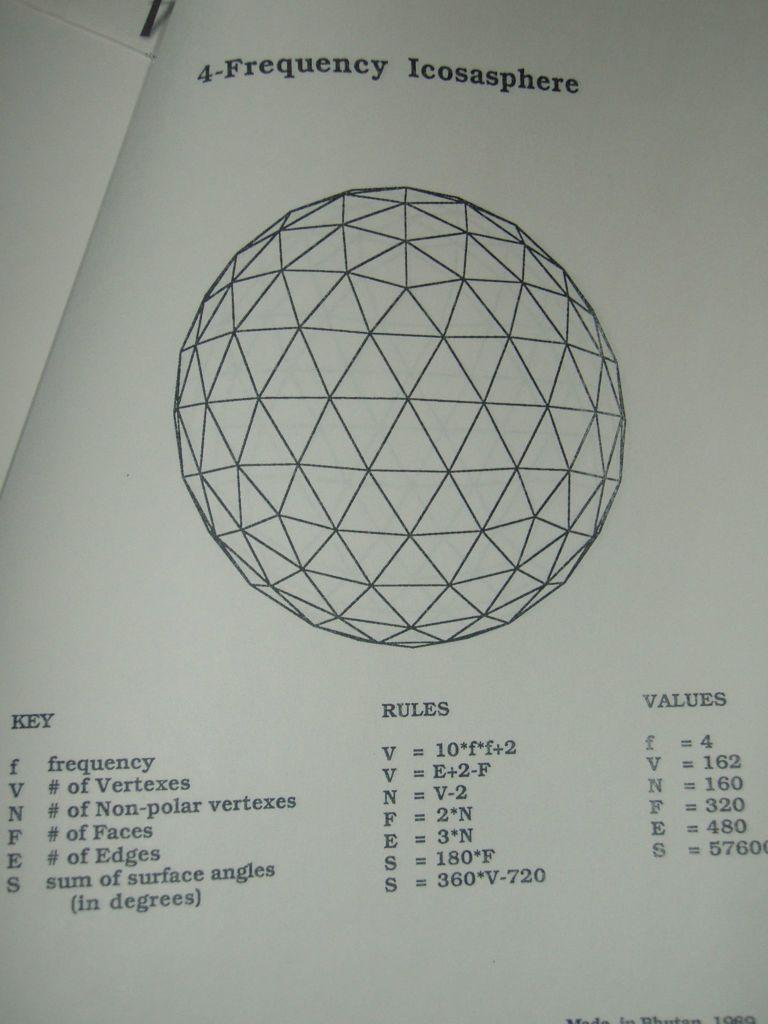What shape is on the paper in the image? There is a sphere on the paper. What else can be seen on the paper besides the sphere? There are notations, formulas, and values on the paper. How many cherries are on the paper in the image? There are no cherries present on the paper in the image. What type of letters can be seen on the paper? There are no letters visible on the paper in the image. 